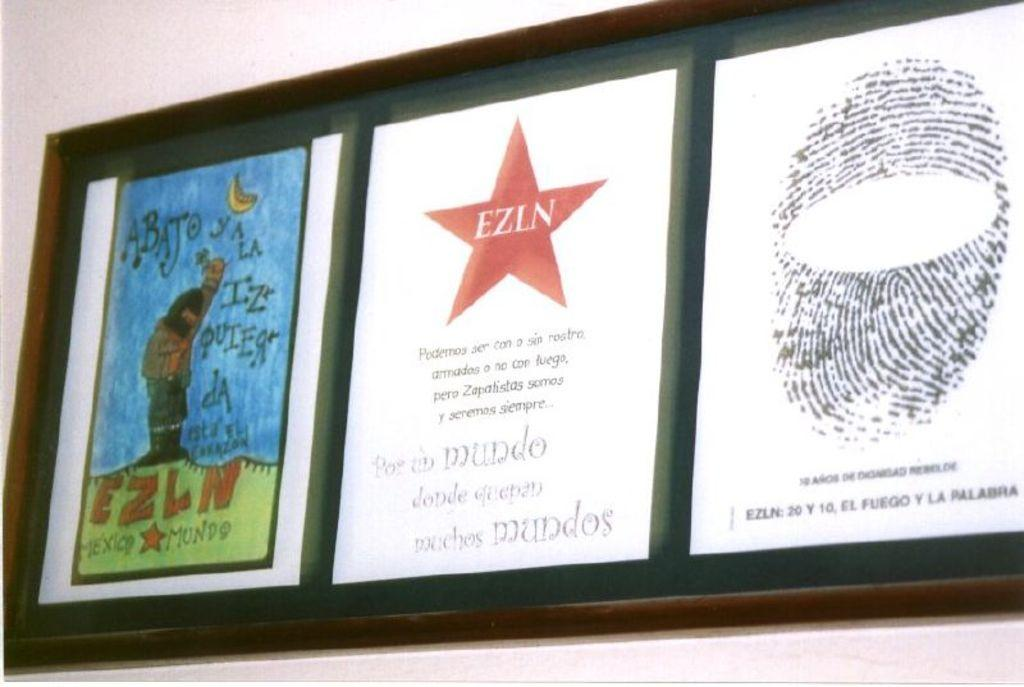What is the main object in the image? There is a board in the image. What is attached to the board? There are three papers pasted on the board. What can be seen on the papers? There is text on the papers. What is visible in the background of the image? There is a wall in the background of the image. What type of rule is being enforced at the airport in the image? There is no airport or rule present in the image; it only features a board with papers pasted on it. 